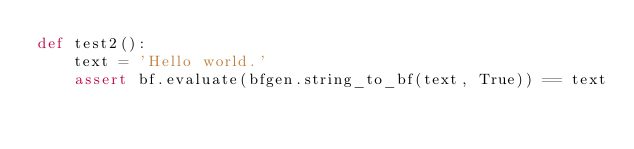Convert code to text. <code><loc_0><loc_0><loc_500><loc_500><_Python_>def test2():
    text = 'Hello world.'
    assert bf.evaluate(bfgen.string_to_bf(text, True)) == text
</code> 